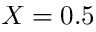Convert formula to latex. <formula><loc_0><loc_0><loc_500><loc_500>X = 0 . 5</formula> 